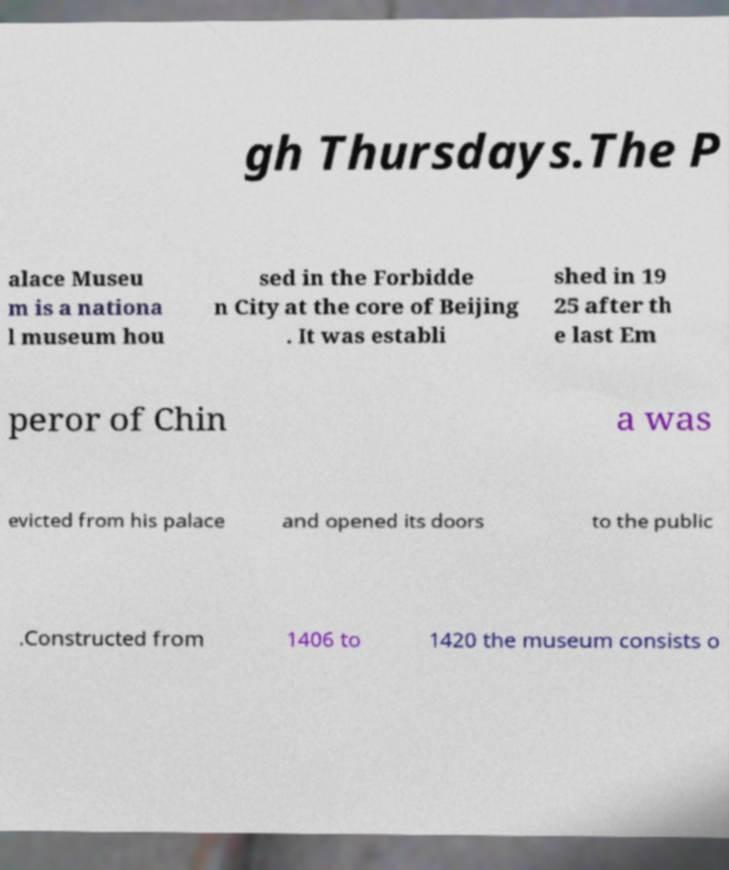Could you extract and type out the text from this image? gh Thursdays.The P alace Museu m is a nationa l museum hou sed in the Forbidde n City at the core of Beijing . It was establi shed in 19 25 after th e last Em peror of Chin a was evicted from his palace and opened its doors to the public .Constructed from 1406 to 1420 the museum consists o 